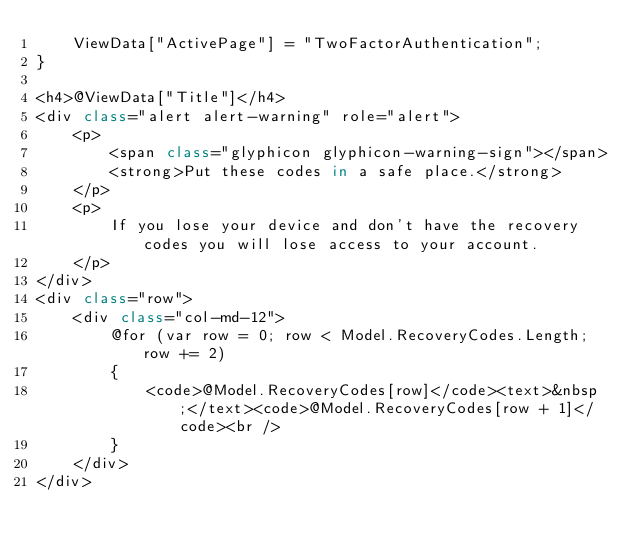Convert code to text. <code><loc_0><loc_0><loc_500><loc_500><_C#_>    ViewData["ActivePage"] = "TwoFactorAuthentication";
}

<h4>@ViewData["Title"]</h4>
<div class="alert alert-warning" role="alert">
    <p>
        <span class="glyphicon glyphicon-warning-sign"></span>
        <strong>Put these codes in a safe place.</strong>
    </p>
    <p>
        If you lose your device and don't have the recovery codes you will lose access to your account.
    </p>
</div>
<div class="row">
    <div class="col-md-12">
        @for (var row = 0; row < Model.RecoveryCodes.Length; row += 2)
        {
            <code>@Model.RecoveryCodes[row]</code><text>&nbsp;</text><code>@Model.RecoveryCodes[row + 1]</code><br />
        }
    </div>
</div></code> 